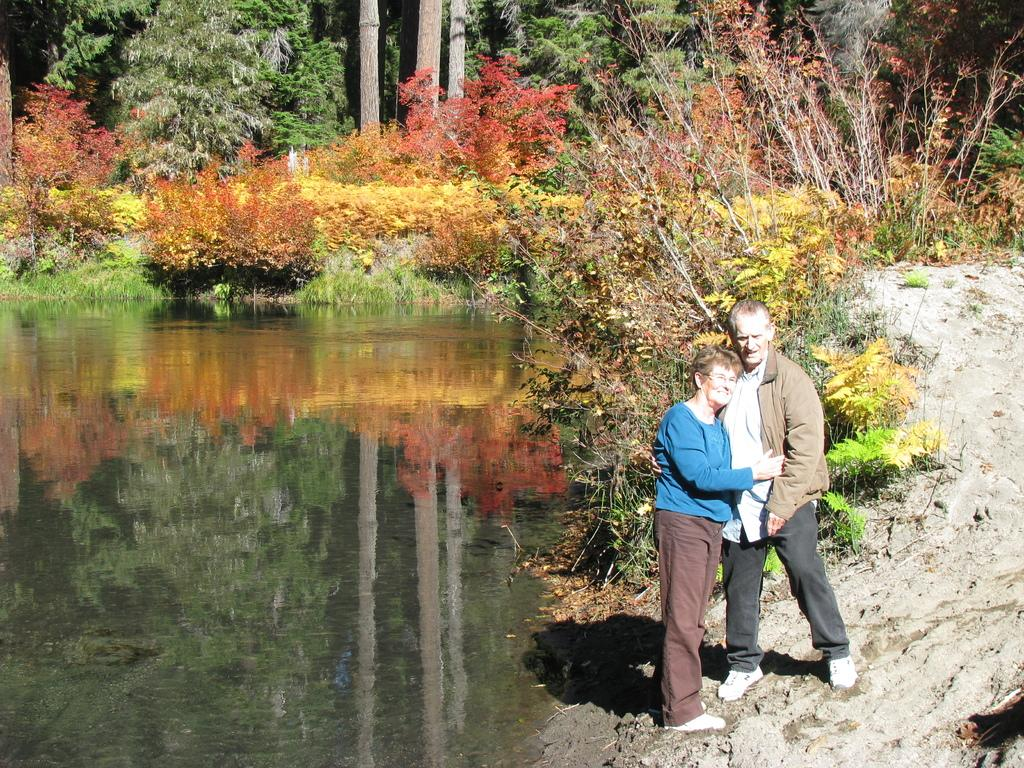How many people are present in the image? There is a man and a woman in the image. What can be seen on the left side of the image? There is water on the left side of the image. What is visible in the background of the image? There are trees in the background of the image. What type of terrain is on the right side of the image? There is sand on the right side of the image. What type of guitar is the man playing in the image? There is no guitar present in the image; the man and woman are not depicted with any musical instruments. 